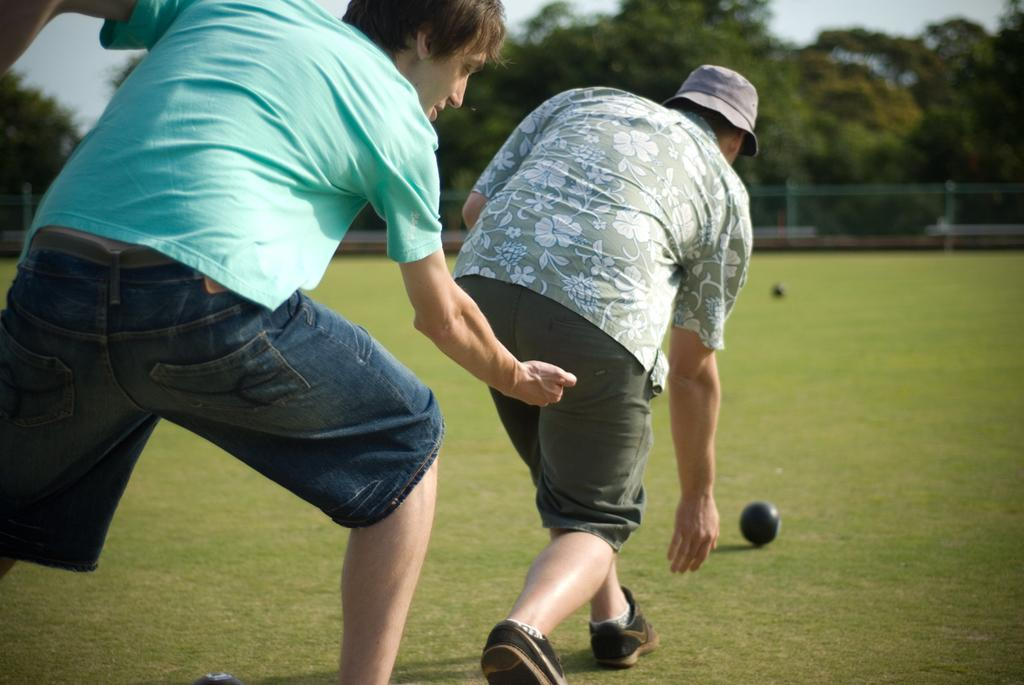How many people are in the image? There are two men standing in the image. What is on the ground near the men? There is a black ball on the ground. What can be seen in the background of the image? There are trees and a fence in the background of the image. What is the opinion of the authority figure in the image? There is no authority figure or opinion present in the image. What type of base is supporting the fence in the image? There is no information about the base supporting the fence in the image? 